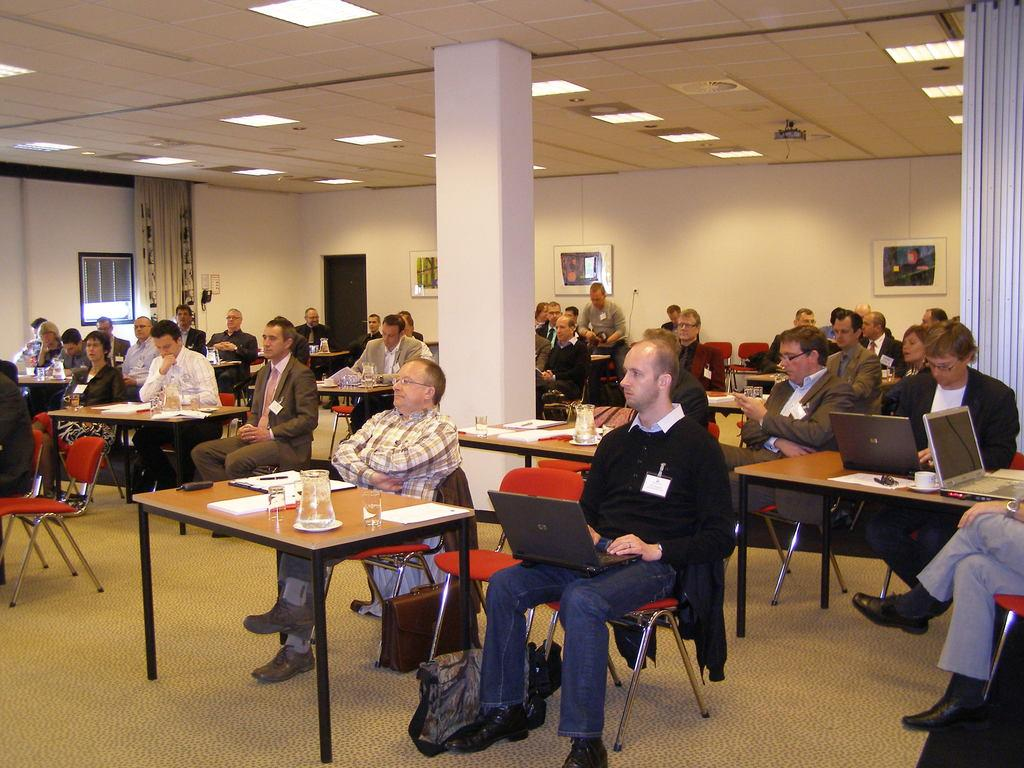What is happening in the image involving a group of people? There is a group of people in the image, and they are sitting on tables. What direction are the people looking in the image? The people are looking at the left side in the image. What can be seen at the top of the image? There is a light at the top of the image. What objects are on the tables with the people? There are glasses on the tables. Can you see a bee buzzing around the people in the image? No, there is no bee present in the image. How many thumbs are visible on the people's hands in the image? The image does not show the people's hands, so it is impossible to determine the number of thumbs visible. 